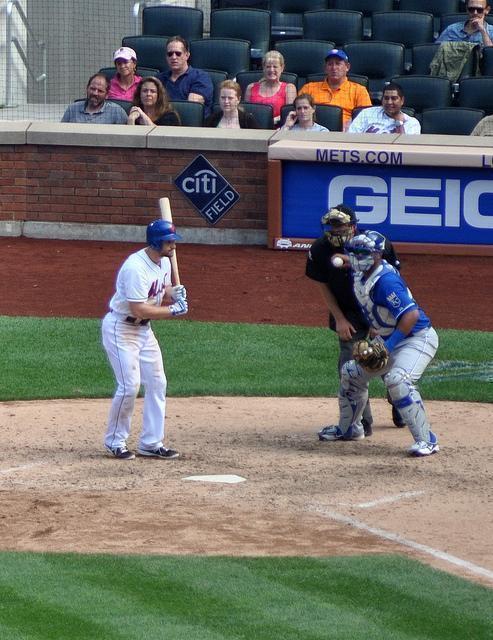Whose home field stadium is this?
Choose the correct response, then elucidate: 'Answer: answer
Rationale: rationale.'
Options: Mariners, yankees, rockies, mets. Answer: mets.
Rationale: You can see the name on the stands. 